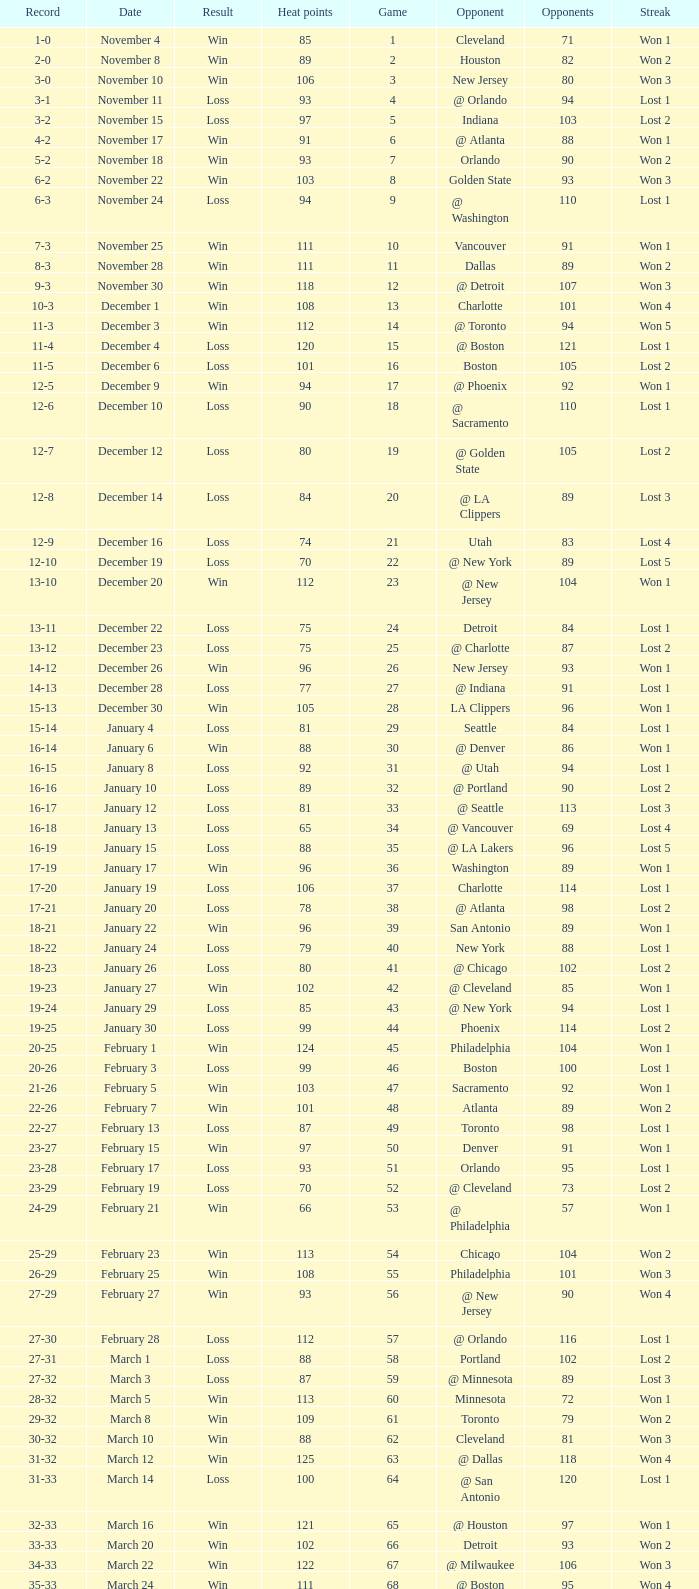What is the average Heat Points, when Result is "Loss", when Game is greater than 72, and when Date is "April 21"? 92.0. 